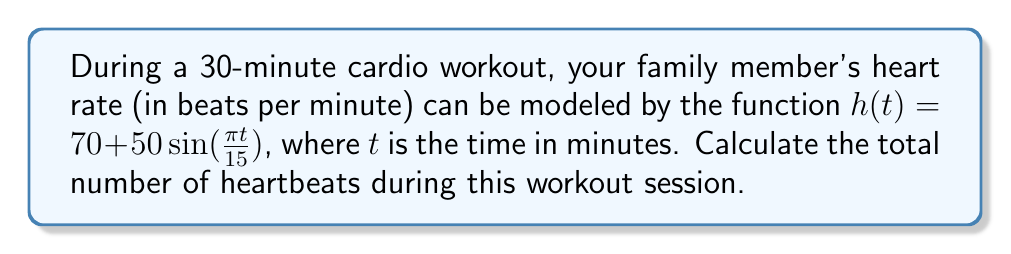Help me with this question. To find the total number of heartbeats, we need to integrate the heart rate function over the 30-minute interval:

1) Set up the definite integral:
   $$\int_0^{30} h(t) \, dt = \int_0^{30} \left(70 + 50\sin\left(\frac{\pi t}{15}\right)\right) \, dt$$

2) Split the integral:
   $$\int_0^{30} 70 \, dt + \int_0^{30} 50\sin\left(\frac{\pi t}{15}\right) \, dt$$

3) Evaluate the first integral:
   $$70t \Big|_0^{30} + \int_0^{30} 50\sin\left(\frac{\pi t}{15}\right) \, dt$$
   $$= 2100 + \int_0^{30} 50\sin\left(\frac{\pi t}{15}\right) \, dt$$

4) For the second integral, use substitution:
   Let $u = \frac{\pi t}{15}$, then $du = \frac{\pi}{15} dt$ and $dt = \frac{15}{\pi} du$
   When $t = 0$, $u = 0$; when $t = 30$, $u = 2\pi$

5) Rewrite the second integral:
   $$2100 + \frac{750}{\pi} \int_0^{2\pi} \sin(u) \, du$$

6) Evaluate:
   $$2100 + \frac{750}{\pi} [-\cos(u)]_0^{2\pi}$$
   $$= 2100 + \frac{750}{\pi} [-\cos(2\pi) + \cos(0)]$$
   $$= 2100 + \frac{750}{\pi} [0] = 2100$$

Therefore, the total number of heartbeats during the 30-minute workout is 2100.
Answer: 2100 heartbeats 